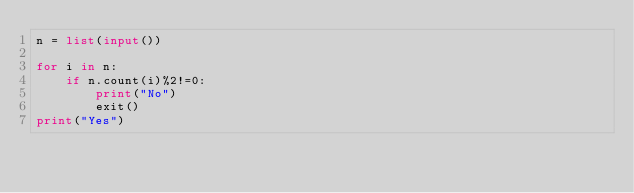Convert code to text. <code><loc_0><loc_0><loc_500><loc_500><_Python_>n = list(input())

for i in n:
    if n.count(i)%2!=0:
        print("No")
        exit()
print("Yes")</code> 